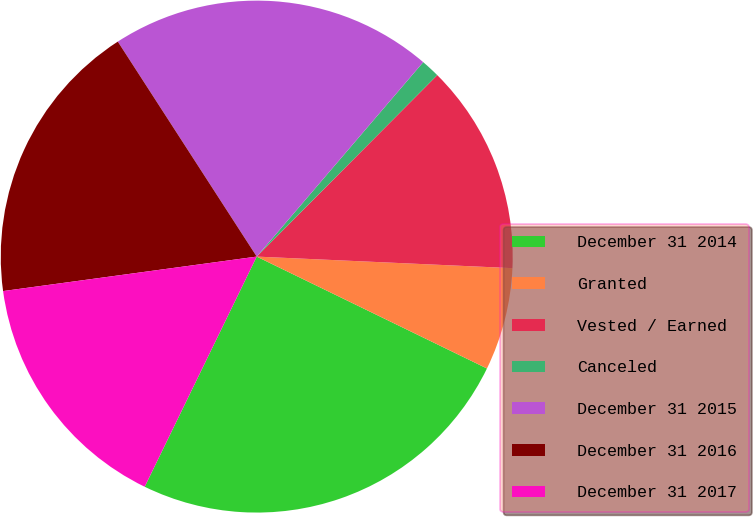Convert chart. <chart><loc_0><loc_0><loc_500><loc_500><pie_chart><fcel>December 31 2014<fcel>Granted<fcel>Vested / Earned<fcel>Canceled<fcel>December 31 2015<fcel>December 31 2016<fcel>December 31 2017<nl><fcel>25.01%<fcel>6.48%<fcel>13.26%<fcel>1.19%<fcel>20.4%<fcel>18.02%<fcel>15.64%<nl></chart> 